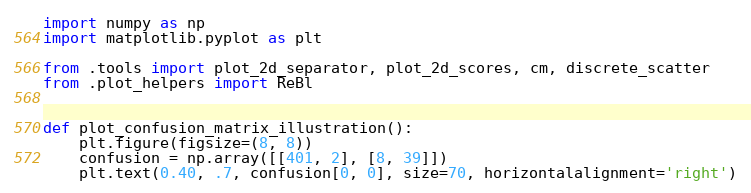<code> <loc_0><loc_0><loc_500><loc_500><_Python_>import numpy as np
import matplotlib.pyplot as plt

from .tools import plot_2d_separator, plot_2d_scores, cm, discrete_scatter
from .plot_helpers import ReBl


def plot_confusion_matrix_illustration():
    plt.figure(figsize=(8, 8))
    confusion = np.array([[401, 2], [8, 39]])
    plt.text(0.40, .7, confusion[0, 0], size=70, horizontalalignment='right')</code> 